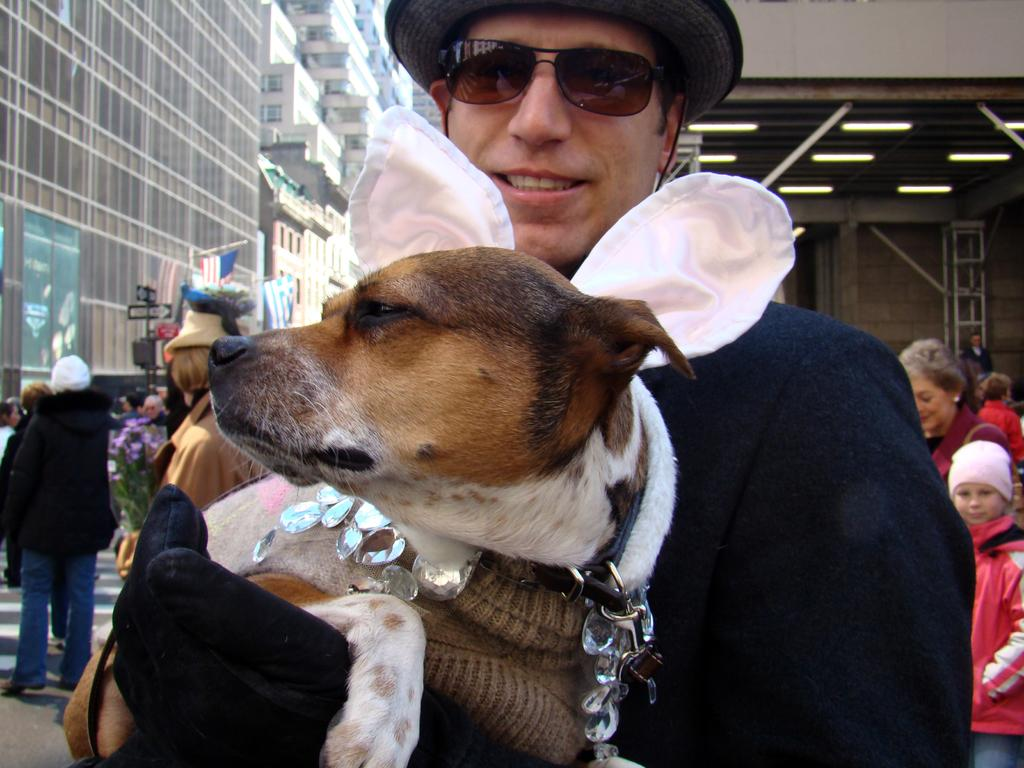Who is the main subject in the image? There is a man in the image. What is the man doing in the image? The man is holding a dog. Are there any other people in the image? Yes, there is a group of people in the image. Where are the people standing in the image? The people are standing on a road. What type of cloud can be seen in the image? There is no cloud visible in the image. Is there a notebook present in the image? There is no notebook present in the image. 